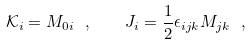<formula> <loc_0><loc_0><loc_500><loc_500>\mathcal { K } _ { i } = M _ { 0 i } \ , \quad J _ { i } = \frac { 1 } { 2 } \epsilon _ { i j k } M _ { j k } \ ,</formula> 